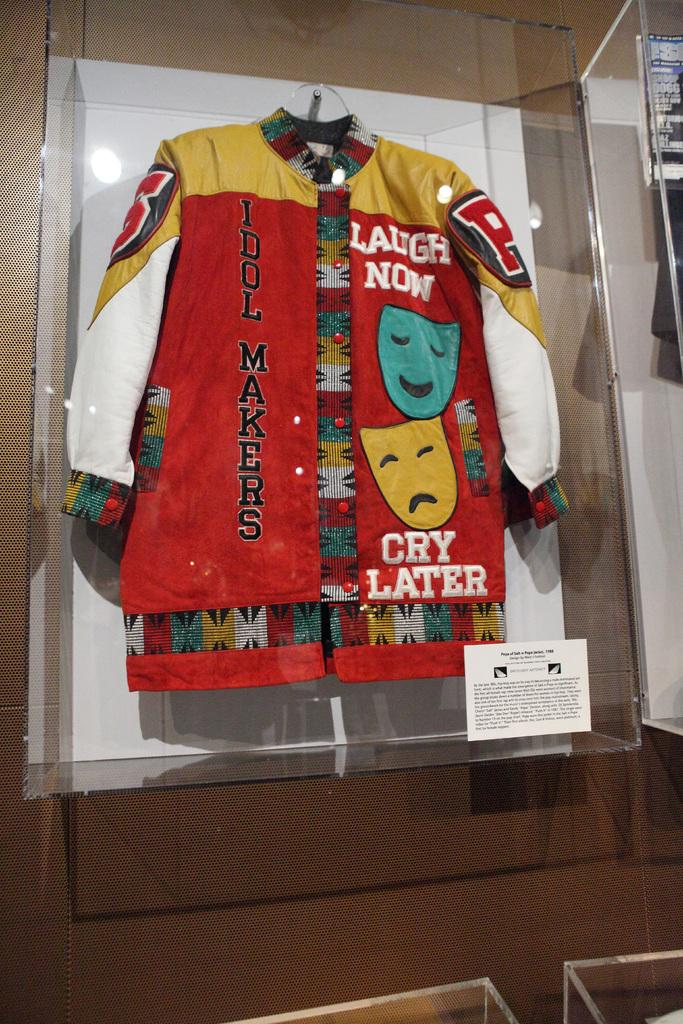<image>
Render a clear and concise summary of the photo. a coat that says idol makers laugh now cry later 